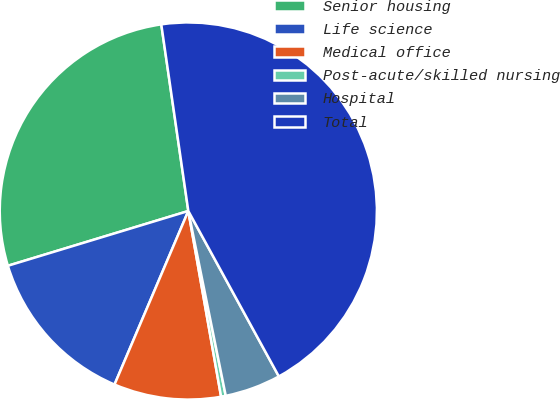Convert chart to OTSL. <chart><loc_0><loc_0><loc_500><loc_500><pie_chart><fcel>Senior housing<fcel>Life science<fcel>Medical office<fcel>Post-acute/skilled nursing<fcel>Hospital<fcel>Total<nl><fcel>27.4%<fcel>13.91%<fcel>9.18%<fcel>0.4%<fcel>4.79%<fcel>44.32%<nl></chart> 